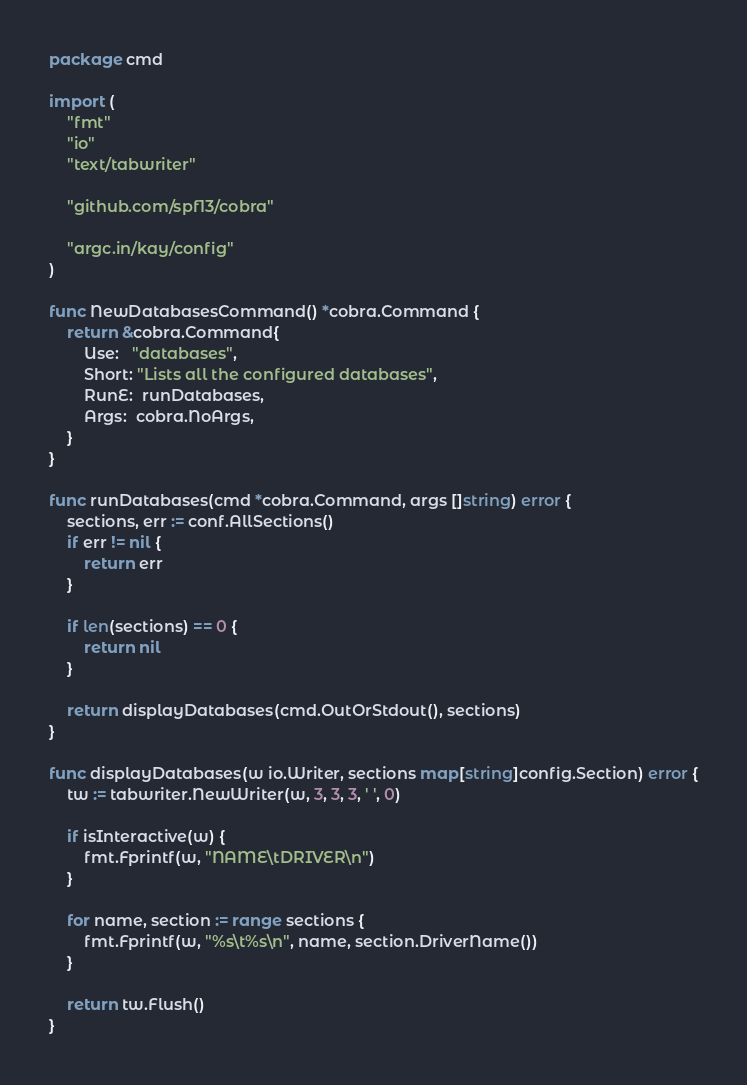Convert code to text. <code><loc_0><loc_0><loc_500><loc_500><_Go_>package cmd

import (
	"fmt"
	"io"
	"text/tabwriter"

	"github.com/spf13/cobra"

	"argc.in/kay/config"
)

func NewDatabasesCommand() *cobra.Command {
	return &cobra.Command{
		Use:   "databases",
		Short: "Lists all the configured databases",
		RunE:  runDatabases,
		Args:  cobra.NoArgs,
	}
}

func runDatabases(cmd *cobra.Command, args []string) error {
	sections, err := conf.AllSections()
	if err != nil {
		return err
	}

	if len(sections) == 0 {
		return nil
	}

	return displayDatabases(cmd.OutOrStdout(), sections)
}

func displayDatabases(w io.Writer, sections map[string]config.Section) error {
	tw := tabwriter.NewWriter(w, 3, 3, 3, ' ', 0)

	if isInteractive(w) {
		fmt.Fprintf(w, "NAME\tDRIVER\n")
	}

	for name, section := range sections {
		fmt.Fprintf(w, "%s\t%s\n", name, section.DriverName())
	}

	return tw.Flush()
}
</code> 